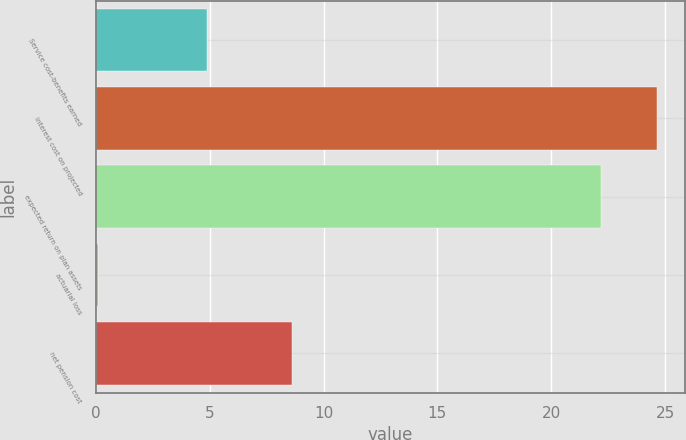Convert chart. <chart><loc_0><loc_0><loc_500><loc_500><bar_chart><fcel>Service cost-benefits earned<fcel>interest cost on projected<fcel>expected return on plan assets<fcel>actuarial loss<fcel>net pension cost<nl><fcel>4.9<fcel>24.64<fcel>22.2<fcel>0.1<fcel>8.6<nl></chart> 